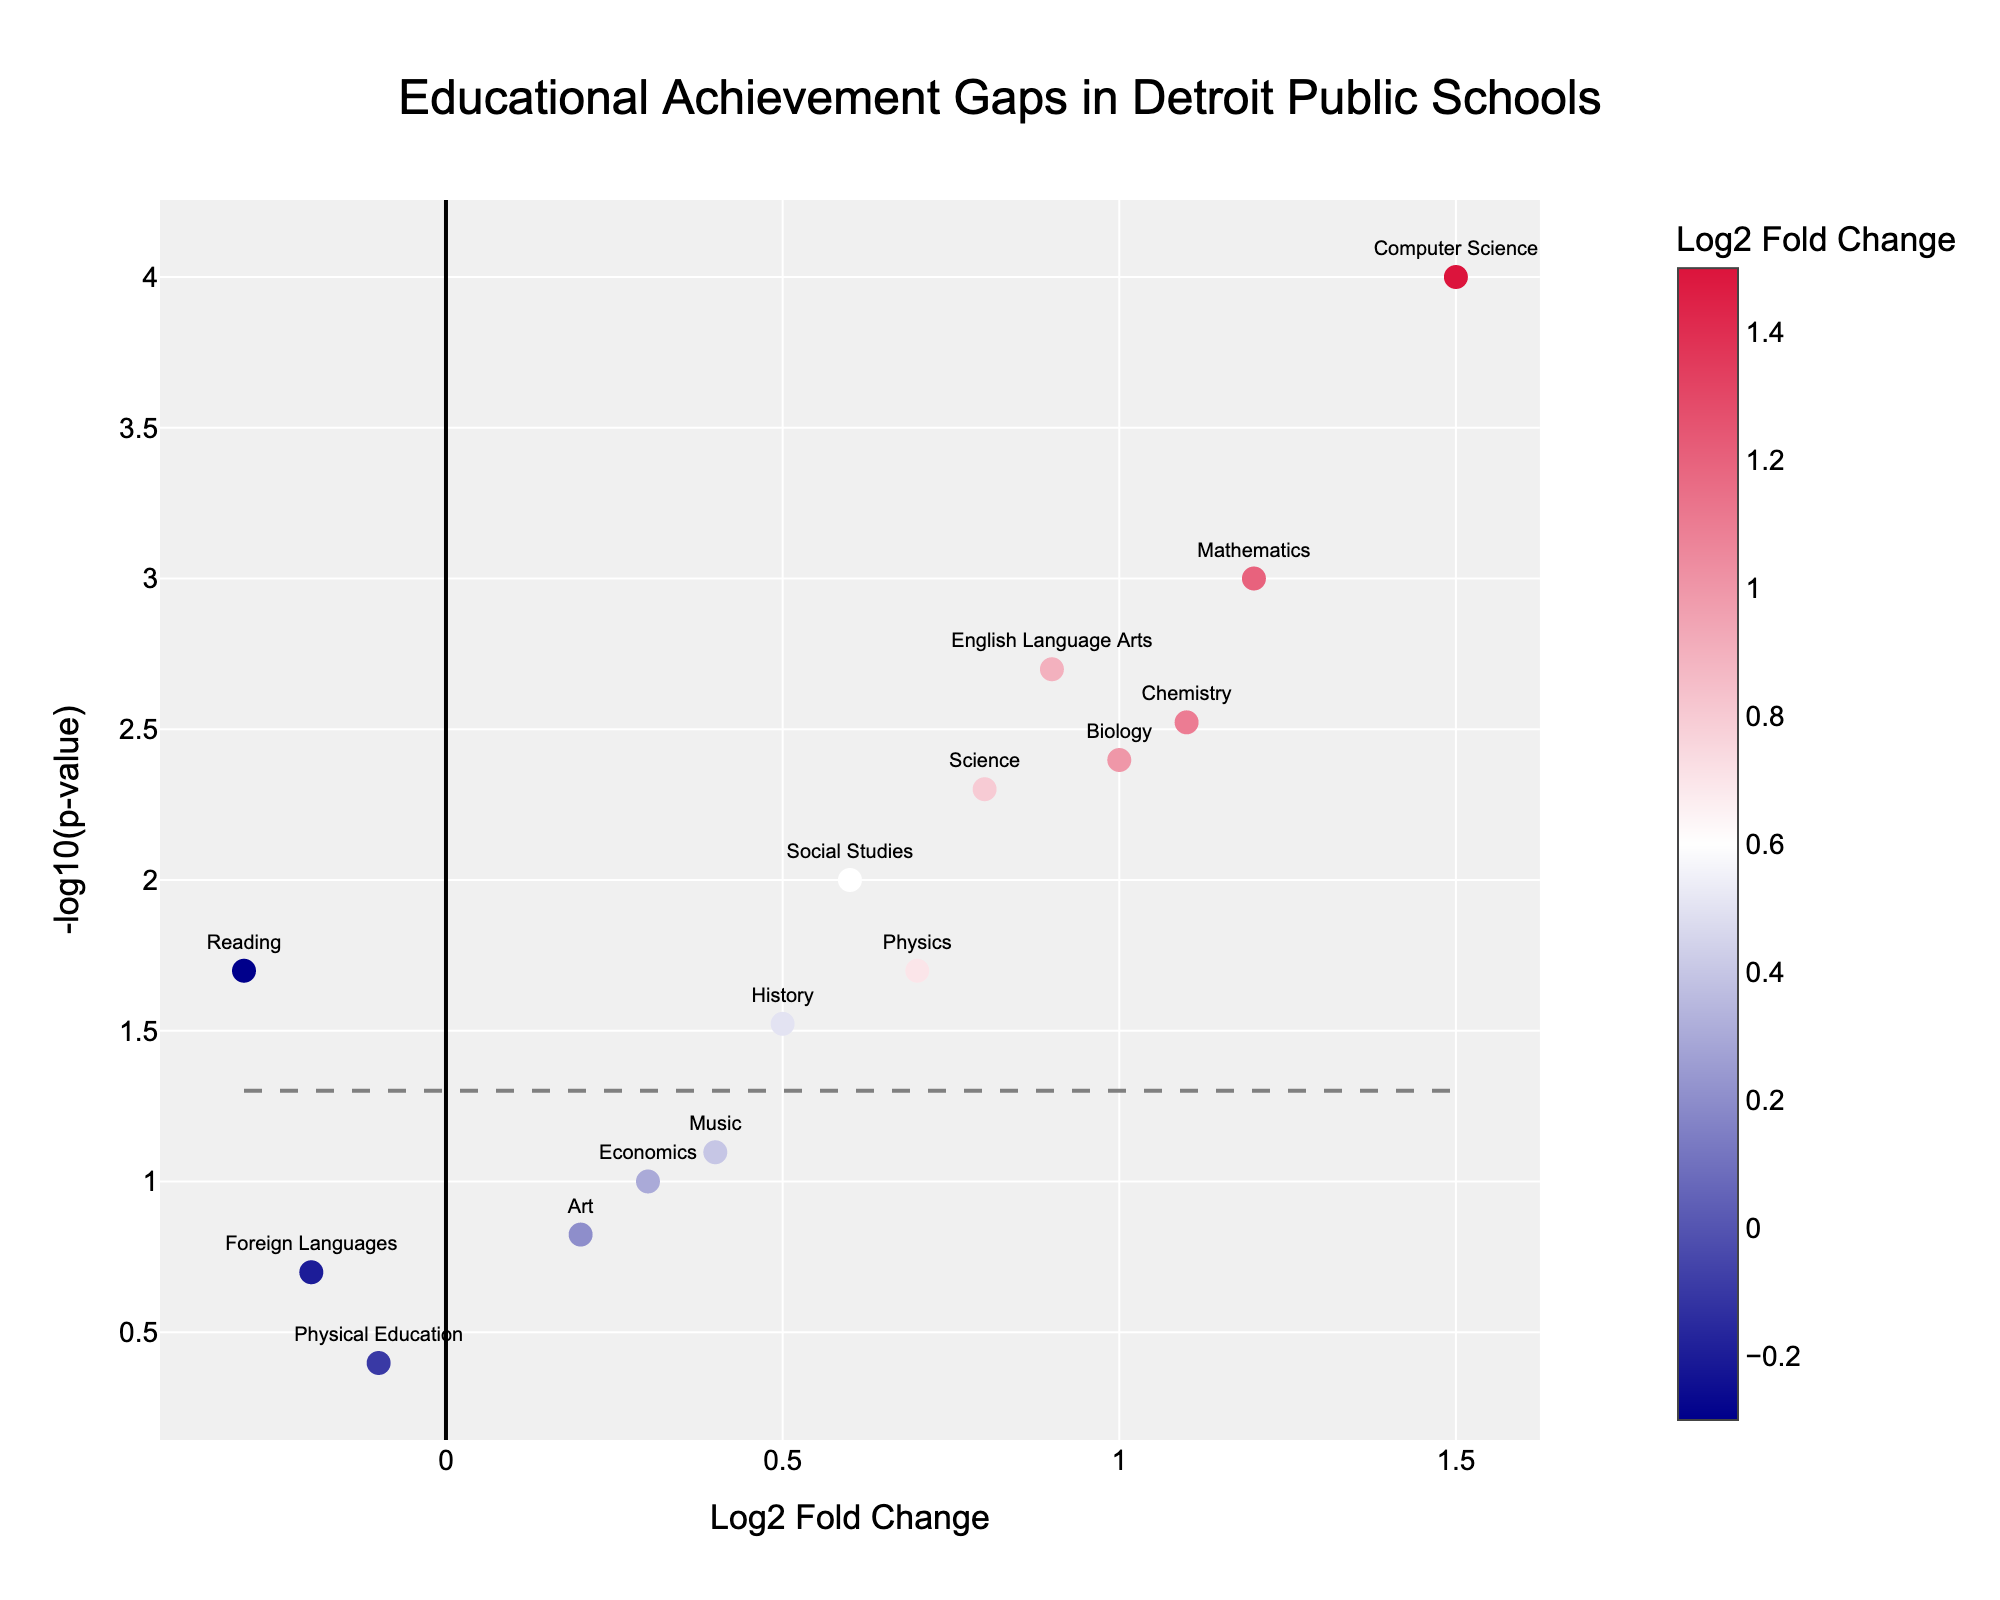How many subjects are represented in the figure? To determine the number of subjects, count the distinct data points labeled directly in the plot. Each label stands for a unique subject in this volcano plot.
Answer: 15 Which subject showed the most significant improvement in educational achievement? The most significant improvement can be identified by looking for the highest Log2 Fold Change value. The subject with the highest positive Log2 Fold Change provides the largest improvement.
Answer: Computer Science What's the Log2 Fold Change and p-value for Mathematics? Look at the plot's x-axis for Log2 Fold Change and the y-axis for -log10(p-value). Identify the Mathematics data point and read off its coordinates accordingly.
Answer: Log2FC: 1.2, p-value: 0.001 Which subject had the least statistical significance for its changes? For the least statistical significance, we need the highest p-value. This is visible as the lowest point on the y-axis (-log10(p-value)), interpreting which data point is closest to the bottom.
Answer: Physical Education What is the -log10(p-value) threshold indicated by the dashed horizontal line, and why is it significant? The dashed line represents a commonly-used significance threshold where p-value = 0.05, which converts to -log10(0.05).
Answer: 1.3 Compare Biology and English Language Arts in terms of their improvement and statistical significance. For comparison, note that Biology has Log2 Fold Change = 1.0 and -log10(p-value) of about 2.4, while English Language Arts has Log2 Fold Change = 0.9 and -log10(p-value) of about 2.7. Compare their values.
Answer: Biology: Moderate improvement, significant; ELA: Slightly less improvement, more significant Which subjects show a decline in educational achievement, and what are their p-values? Subjects with negative Log2 Fold Change values indicate decline. Check the left side of the plot on the x-axis for those with negative values and note their p-values from the y-axis.
Answer: Reading, Physical Education, Foreign Languages For Music: How does its improvement and significance compare to Science? Check the positions of Music and Science in the plot. Music has a smaller Log2 Fold Change and higher p-value than Science. Music: Log2FC = 0.4, Science: Log2FC = 0.8. Compare their y-axis positions too.
Answer: Music: Less improvement, less significant; Science: More improvement, more significant What overall trend do you observe regarding Math-based subjects like Mathematics, Computer Science, Chemistry, and Physics? By examining the positions of these subjects on the positive side of Log2 Fold Change and above the significance threshold, it shows they generally improved and are statistically significant.
Answer: Mostly positive improvement and significant 